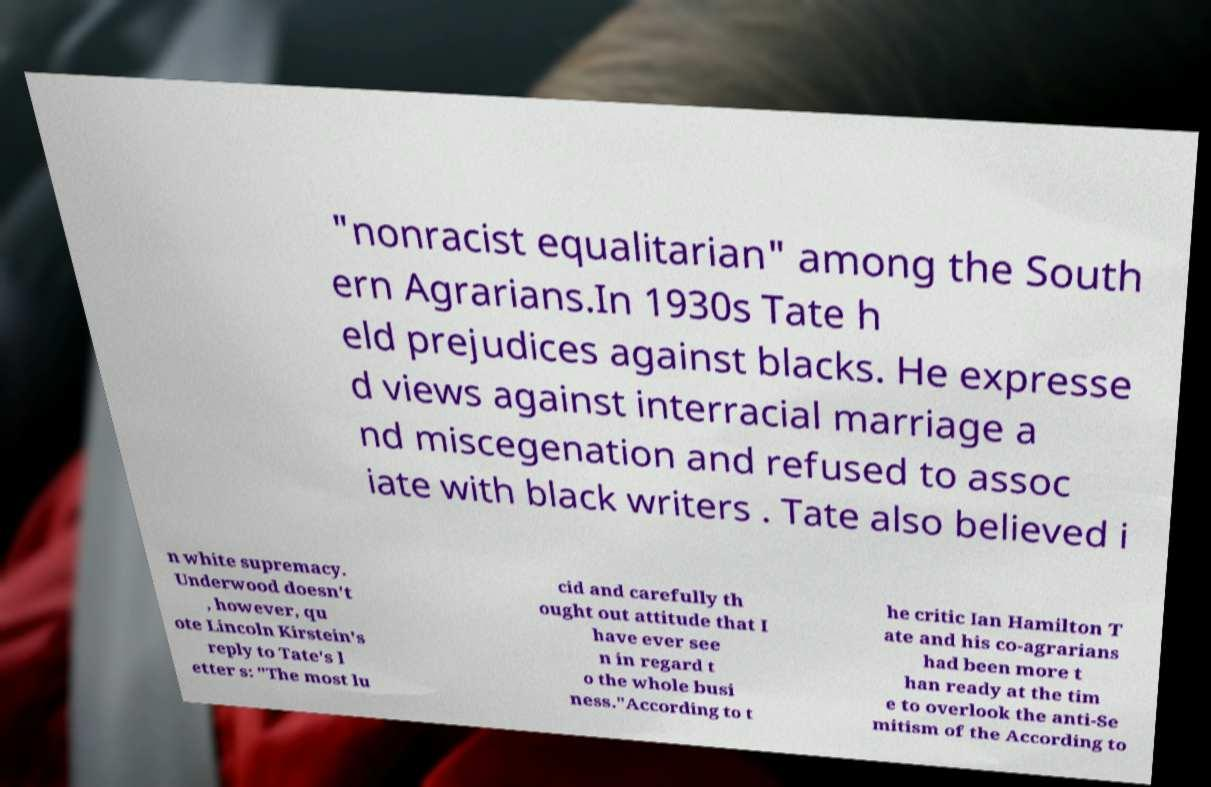Please identify and transcribe the text found in this image. "nonracist equalitarian" among the South ern Agrarians.In 1930s Tate h eld prejudices against blacks. He expresse d views against interracial marriage a nd miscegenation and refused to assoc iate with black writers . Tate also believed i n white supremacy. Underwood doesn't , however, qu ote Lincoln Kirstein's reply to Tate's l etter s: "The most lu cid and carefully th ought out attitude that I have ever see n in regard t o the whole busi ness."According to t he critic Ian Hamilton T ate and his co-agrarians had been more t han ready at the tim e to overlook the anti-Se mitism of the According to 